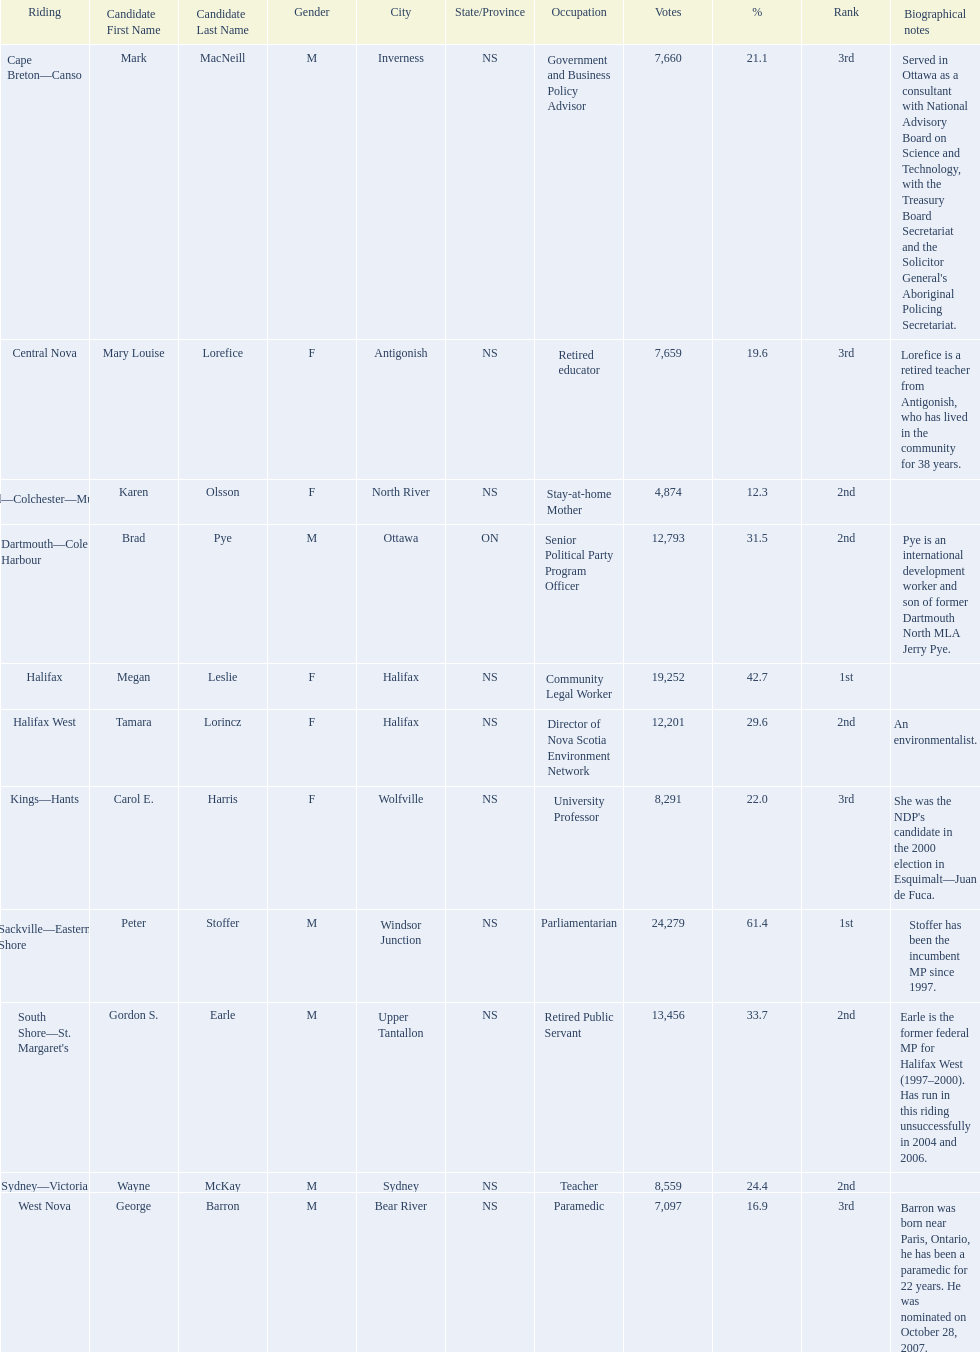What new democratic party candidates ran in the 2008 canadian federal election? Mark MacNeill, Mary Louise Lorefice, Karen Olsson, Brad Pye, Megan Leslie, Tamara Lorincz, Carol E. Harris, Peter Stoffer, Gordon S. Earle, Wayne McKay, George Barron. Of these candidates, which are female? Mary Louise Lorefice, Karen Olsson, Megan Leslie, Tamara Lorincz, Carol E. Harris. Which of these candidates resides in halifax? Megan Leslie, Tamara Lorincz. Of the remaining two, which was ranked 1st? Megan Leslie. How many votes did she get? 19,252. 